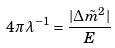<formula> <loc_0><loc_0><loc_500><loc_500>4 \pi \lambda ^ { - 1 } = \frac { | \Delta \tilde { m } ^ { 2 } | } { E }</formula> 